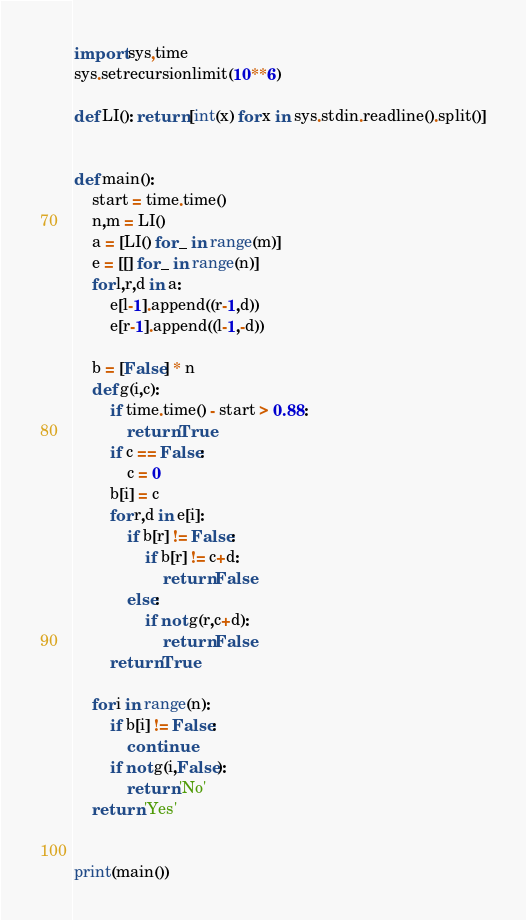<code> <loc_0><loc_0><loc_500><loc_500><_Python_>import sys,time
sys.setrecursionlimit(10**6)

def LI(): return [int(x) for x in sys.stdin.readline().split()]


def main():
    start = time.time()
    n,m = LI()
    a = [LI() for _ in range(m)]
    e = [[] for _ in range(n)]
    for l,r,d in a:
        e[l-1].append((r-1,d))
        e[r-1].append((l-1,-d))

    b = [False] * n
    def g(i,c):
        if time.time() - start > 0.88:
            return True
        if c == False:
            c = 0
        b[i] = c
        for r,d in e[i]:
            if b[r] != False:
                if b[r] != c+d:
                    return False
            else:
                if not g(r,c+d):
                    return False
        return True

    for i in range(n):
        if b[i] != False:
            continue
        if not g(i,False):
            return 'No'
    return 'Yes'


print(main())



</code> 